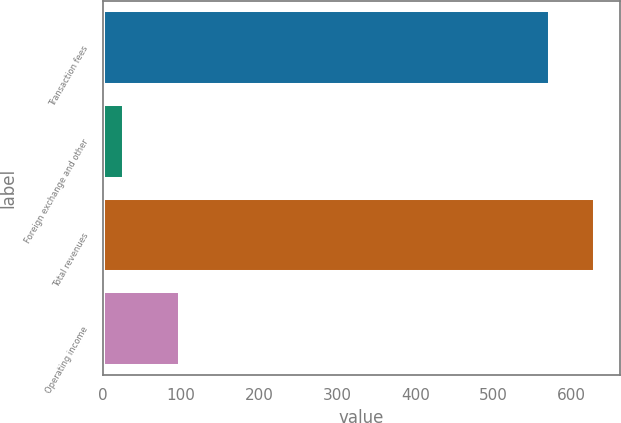Convert chart. <chart><loc_0><loc_0><loc_500><loc_500><bar_chart><fcel>Transaction fees<fcel>Foreign exchange and other<fcel>Total revenues<fcel>Operating income<nl><fcel>572.7<fcel>26.1<fcel>629.97<fcel>98.7<nl></chart> 